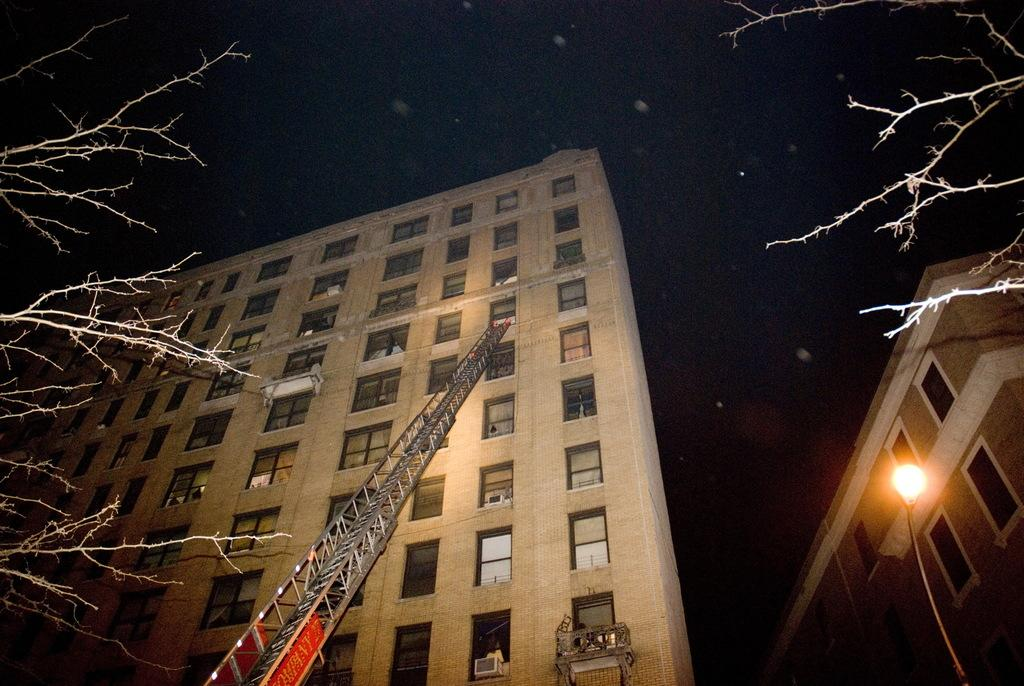What type of structures can be seen in the image? There are buildings in the image. What feature do the buildings have? The buildings have glass windows. What is the purpose of the metal ladder in the image? The metal ladder is likely used for accessing higher levels or maintenance purposes. What is the source of illumination in the image? There is a street light in the image. What type of vegetation is present on both sides of the image? There are trees on both sides of the image. What celestial objects can be seen in the sky? Stars are visible in the sky. What type of whistle can be heard coming from the buildings in the image? There is no whistle present in the image, and therefore no such sound can be heard. 